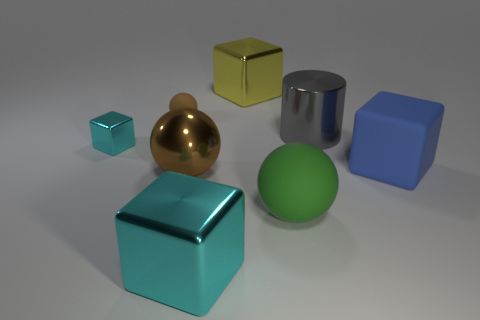Can you describe the different materials and finishes of the objects? Certainly! In the image, there are various objects with different materials and finishes. The small teal-colored object has a metallic sheen. The large cube in the foreground has a teal matte finish. There's a smaller object in a golden color with a reflective metallic finish, probably representing metal or polished brass. The cylindrical object has a shiny, reflective surface, indicating it might be made of steel or chrome. In contrast, the medium-sized green sphere and the blue cube both have a matte finish, suggesting a surface like painted wood or plastic. 